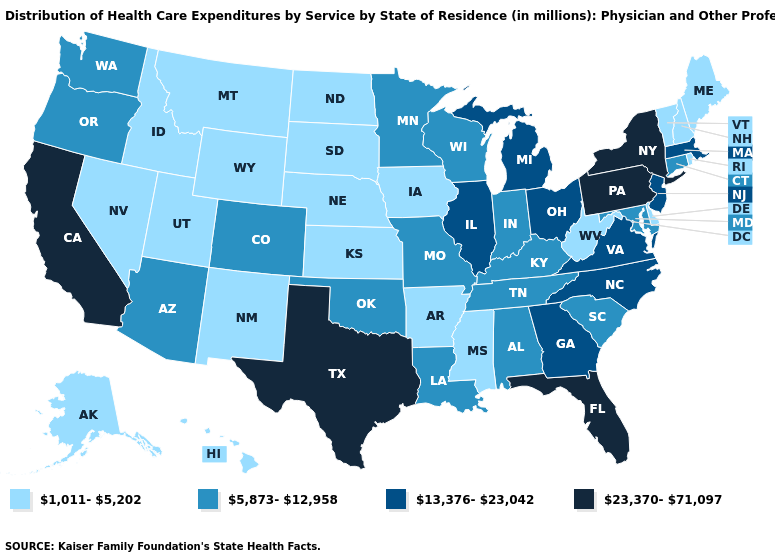Does the first symbol in the legend represent the smallest category?
Give a very brief answer. Yes. Does Delaware have the lowest value in the USA?
Keep it brief. Yes. Which states have the highest value in the USA?
Write a very short answer. California, Florida, New York, Pennsylvania, Texas. Which states have the lowest value in the West?
Write a very short answer. Alaska, Hawaii, Idaho, Montana, Nevada, New Mexico, Utah, Wyoming. Which states have the highest value in the USA?
Quick response, please. California, Florida, New York, Pennsylvania, Texas. What is the lowest value in the USA?
Write a very short answer. 1,011-5,202. Name the states that have a value in the range 1,011-5,202?
Give a very brief answer. Alaska, Arkansas, Delaware, Hawaii, Idaho, Iowa, Kansas, Maine, Mississippi, Montana, Nebraska, Nevada, New Hampshire, New Mexico, North Dakota, Rhode Island, South Dakota, Utah, Vermont, West Virginia, Wyoming. Does Florida have the highest value in the USA?
Be succinct. Yes. What is the highest value in the USA?
Be succinct. 23,370-71,097. What is the highest value in states that border Florida?
Quick response, please. 13,376-23,042. What is the value of North Dakota?
Write a very short answer. 1,011-5,202. What is the value of Oregon?
Be succinct. 5,873-12,958. What is the lowest value in the Northeast?
Keep it brief. 1,011-5,202. Which states hav the highest value in the Northeast?
Give a very brief answer. New York, Pennsylvania. What is the value of West Virginia?
Short answer required. 1,011-5,202. 